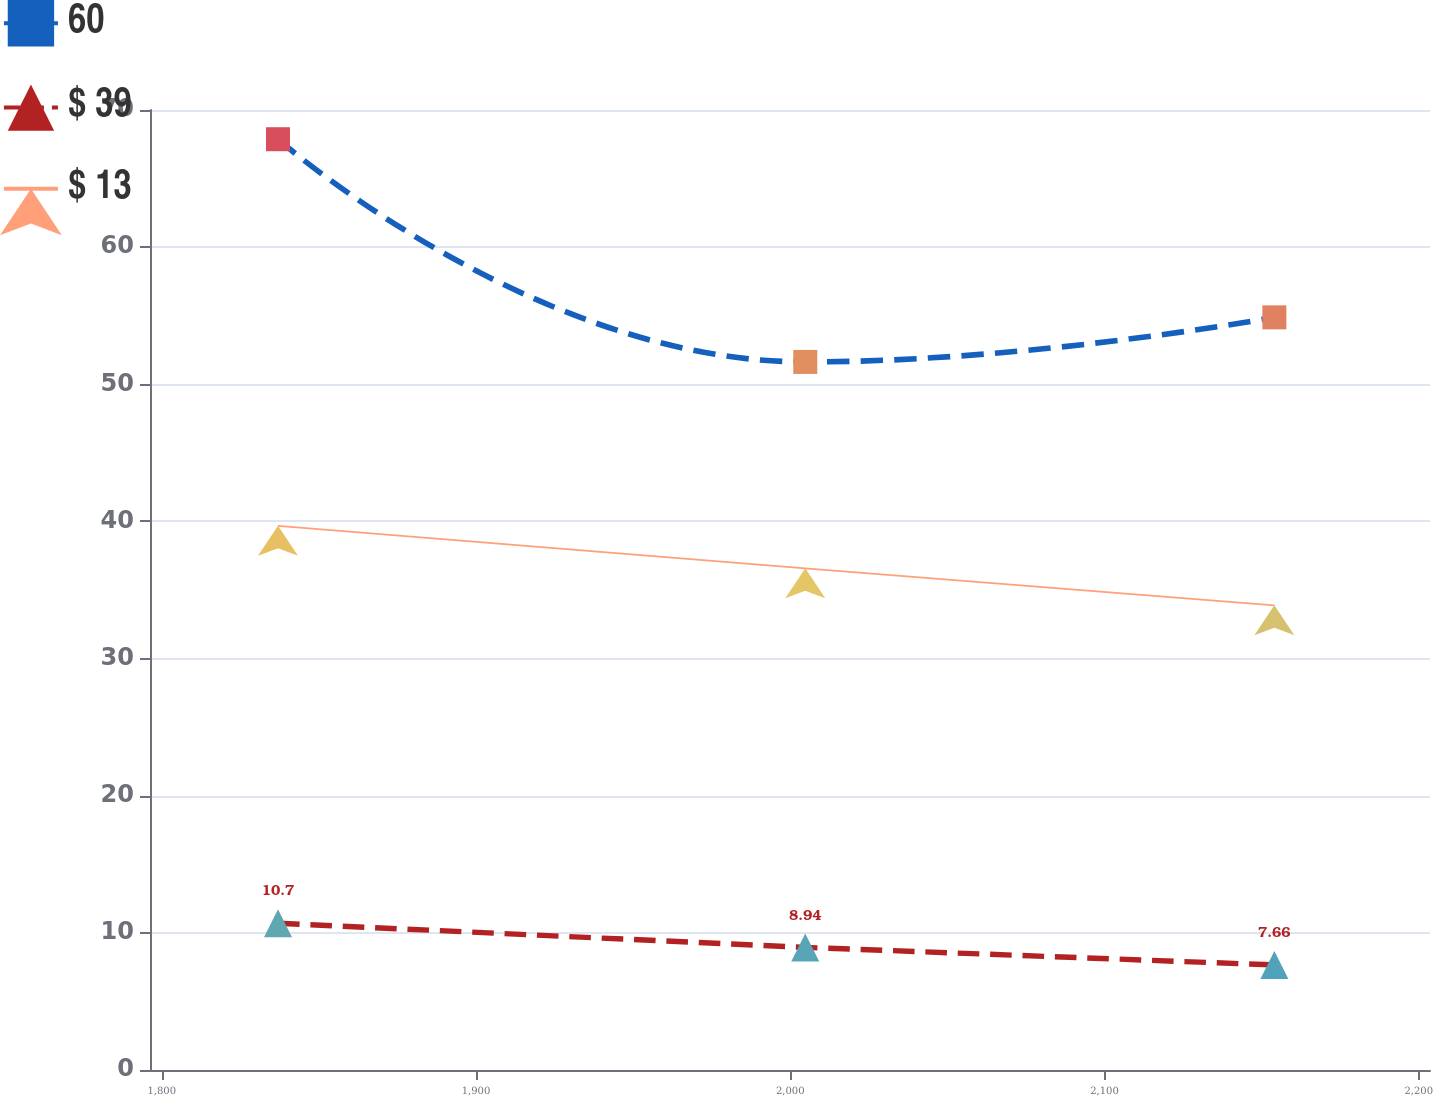Convert chart. <chart><loc_0><loc_0><loc_500><loc_500><line_chart><ecel><fcel>60<fcel>$ 39<fcel>$ 13<nl><fcel>1837.01<fcel>67.87<fcel>10.7<fcel>39.68<nl><fcel>2004.8<fcel>51.63<fcel>8.94<fcel>36.58<nl><fcel>2154.07<fcel>54.88<fcel>7.66<fcel>33.88<nl><fcel>2244.33<fcel>35.34<fcel>7.96<fcel>26.18<nl></chart> 